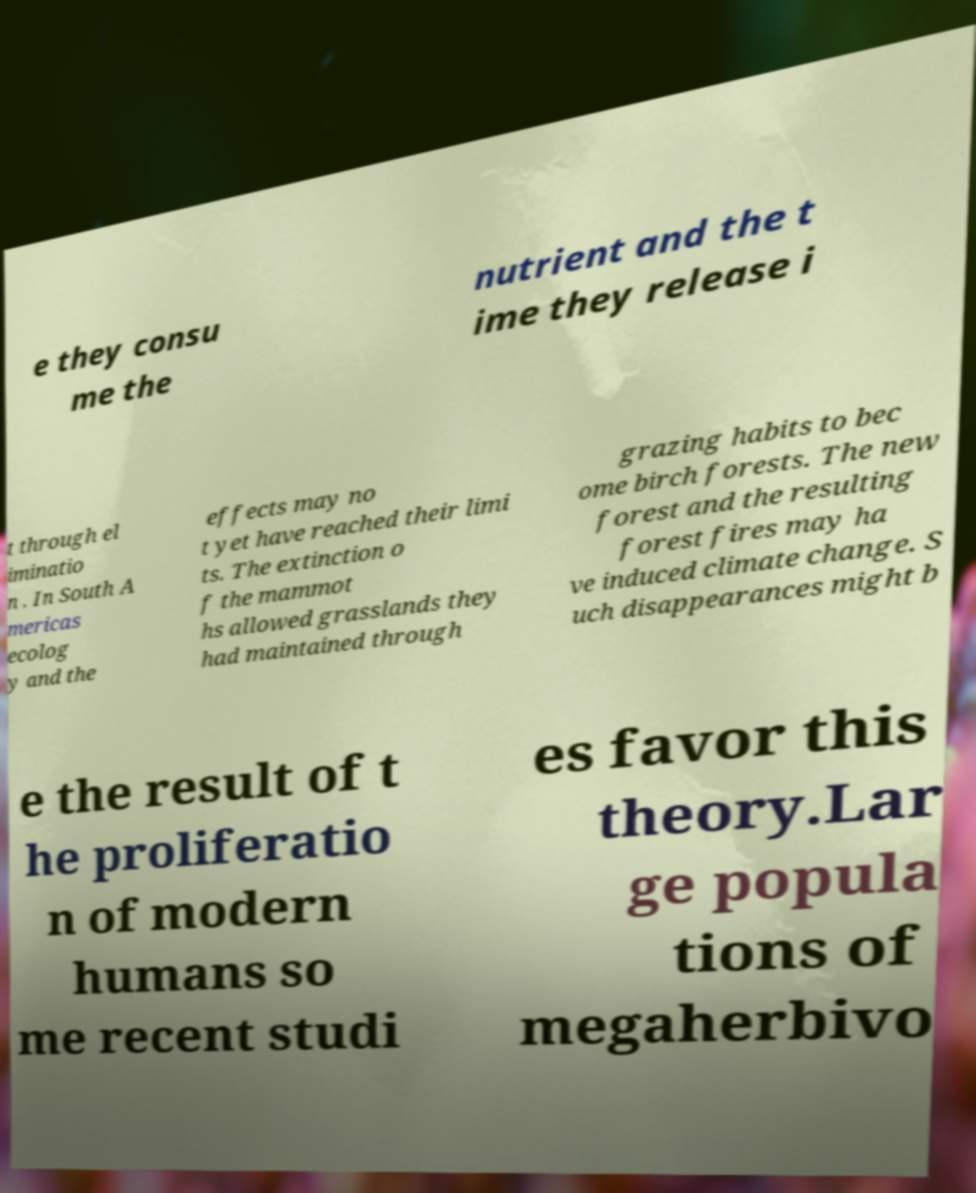Can you read and provide the text displayed in the image?This photo seems to have some interesting text. Can you extract and type it out for me? e they consu me the nutrient and the t ime they release i t through el iminatio n . In South A mericas ecolog y and the effects may no t yet have reached their limi ts. The extinction o f the mammot hs allowed grasslands they had maintained through grazing habits to bec ome birch forests. The new forest and the resulting forest fires may ha ve induced climate change. S uch disappearances might b e the result of t he proliferatio n of modern humans so me recent studi es favor this theory.Lar ge popula tions of megaherbivo 